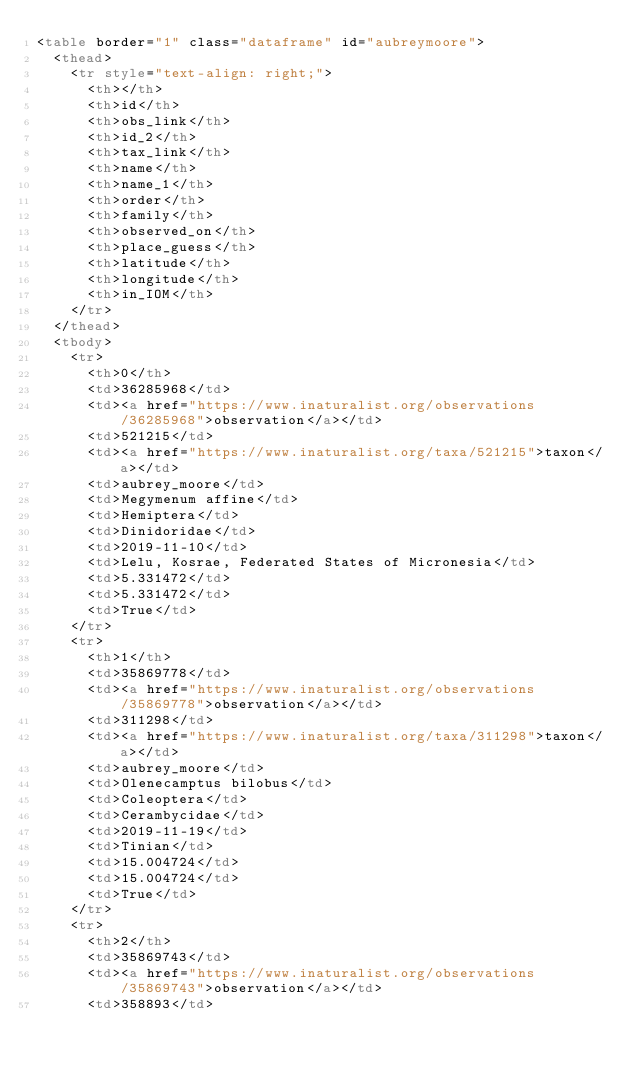<code> <loc_0><loc_0><loc_500><loc_500><_HTML_><table border="1" class="dataframe" id="aubreymoore">
  <thead>
    <tr style="text-align: right;">
      <th></th>
      <th>id</th>
      <th>obs_link</th>
      <th>id_2</th>
      <th>tax_link</th>
      <th>name</th>
      <th>name_1</th>
      <th>order</th>
      <th>family</th>
      <th>observed_on</th>
      <th>place_guess</th>
      <th>latitude</th>
      <th>longitude</th>
      <th>in_IOM</th>
    </tr>
  </thead>
  <tbody>
    <tr>
      <th>0</th>
      <td>36285968</td>
      <td><a href="https://www.inaturalist.org/observations/36285968">observation</a></td>
      <td>521215</td>
      <td><a href="https://www.inaturalist.org/taxa/521215">taxon</a></td>
      <td>aubrey_moore</td>
      <td>Megymenum affine</td>
      <td>Hemiptera</td>
      <td>Dinidoridae</td>
      <td>2019-11-10</td>
      <td>Lelu, Kosrae, Federated States of Micronesia</td>
      <td>5.331472</td>
      <td>5.331472</td>
      <td>True</td>
    </tr>
    <tr>
      <th>1</th>
      <td>35869778</td>
      <td><a href="https://www.inaturalist.org/observations/35869778">observation</a></td>
      <td>311298</td>
      <td><a href="https://www.inaturalist.org/taxa/311298">taxon</a></td>
      <td>aubrey_moore</td>
      <td>Olenecamptus bilobus</td>
      <td>Coleoptera</td>
      <td>Cerambycidae</td>
      <td>2019-11-19</td>
      <td>Tinian</td>
      <td>15.004724</td>
      <td>15.004724</td>
      <td>True</td>
    </tr>
    <tr>
      <th>2</th>
      <td>35869743</td>
      <td><a href="https://www.inaturalist.org/observations/35869743">observation</a></td>
      <td>358893</td></code> 